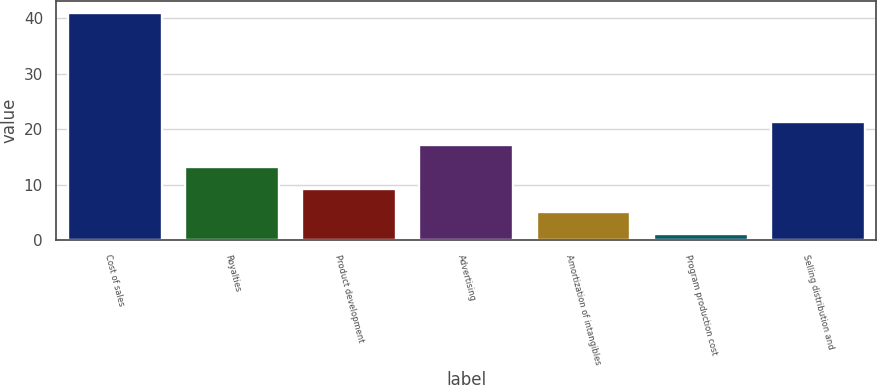Convert chart. <chart><loc_0><loc_0><loc_500><loc_500><bar_chart><fcel>Cost of sales<fcel>Royalties<fcel>Product development<fcel>Advertising<fcel>Amortization of intangibles<fcel>Program production cost<fcel>Selling distribution and<nl><fcel>41<fcel>13.14<fcel>9.16<fcel>17.12<fcel>5.18<fcel>1.2<fcel>21.3<nl></chart> 